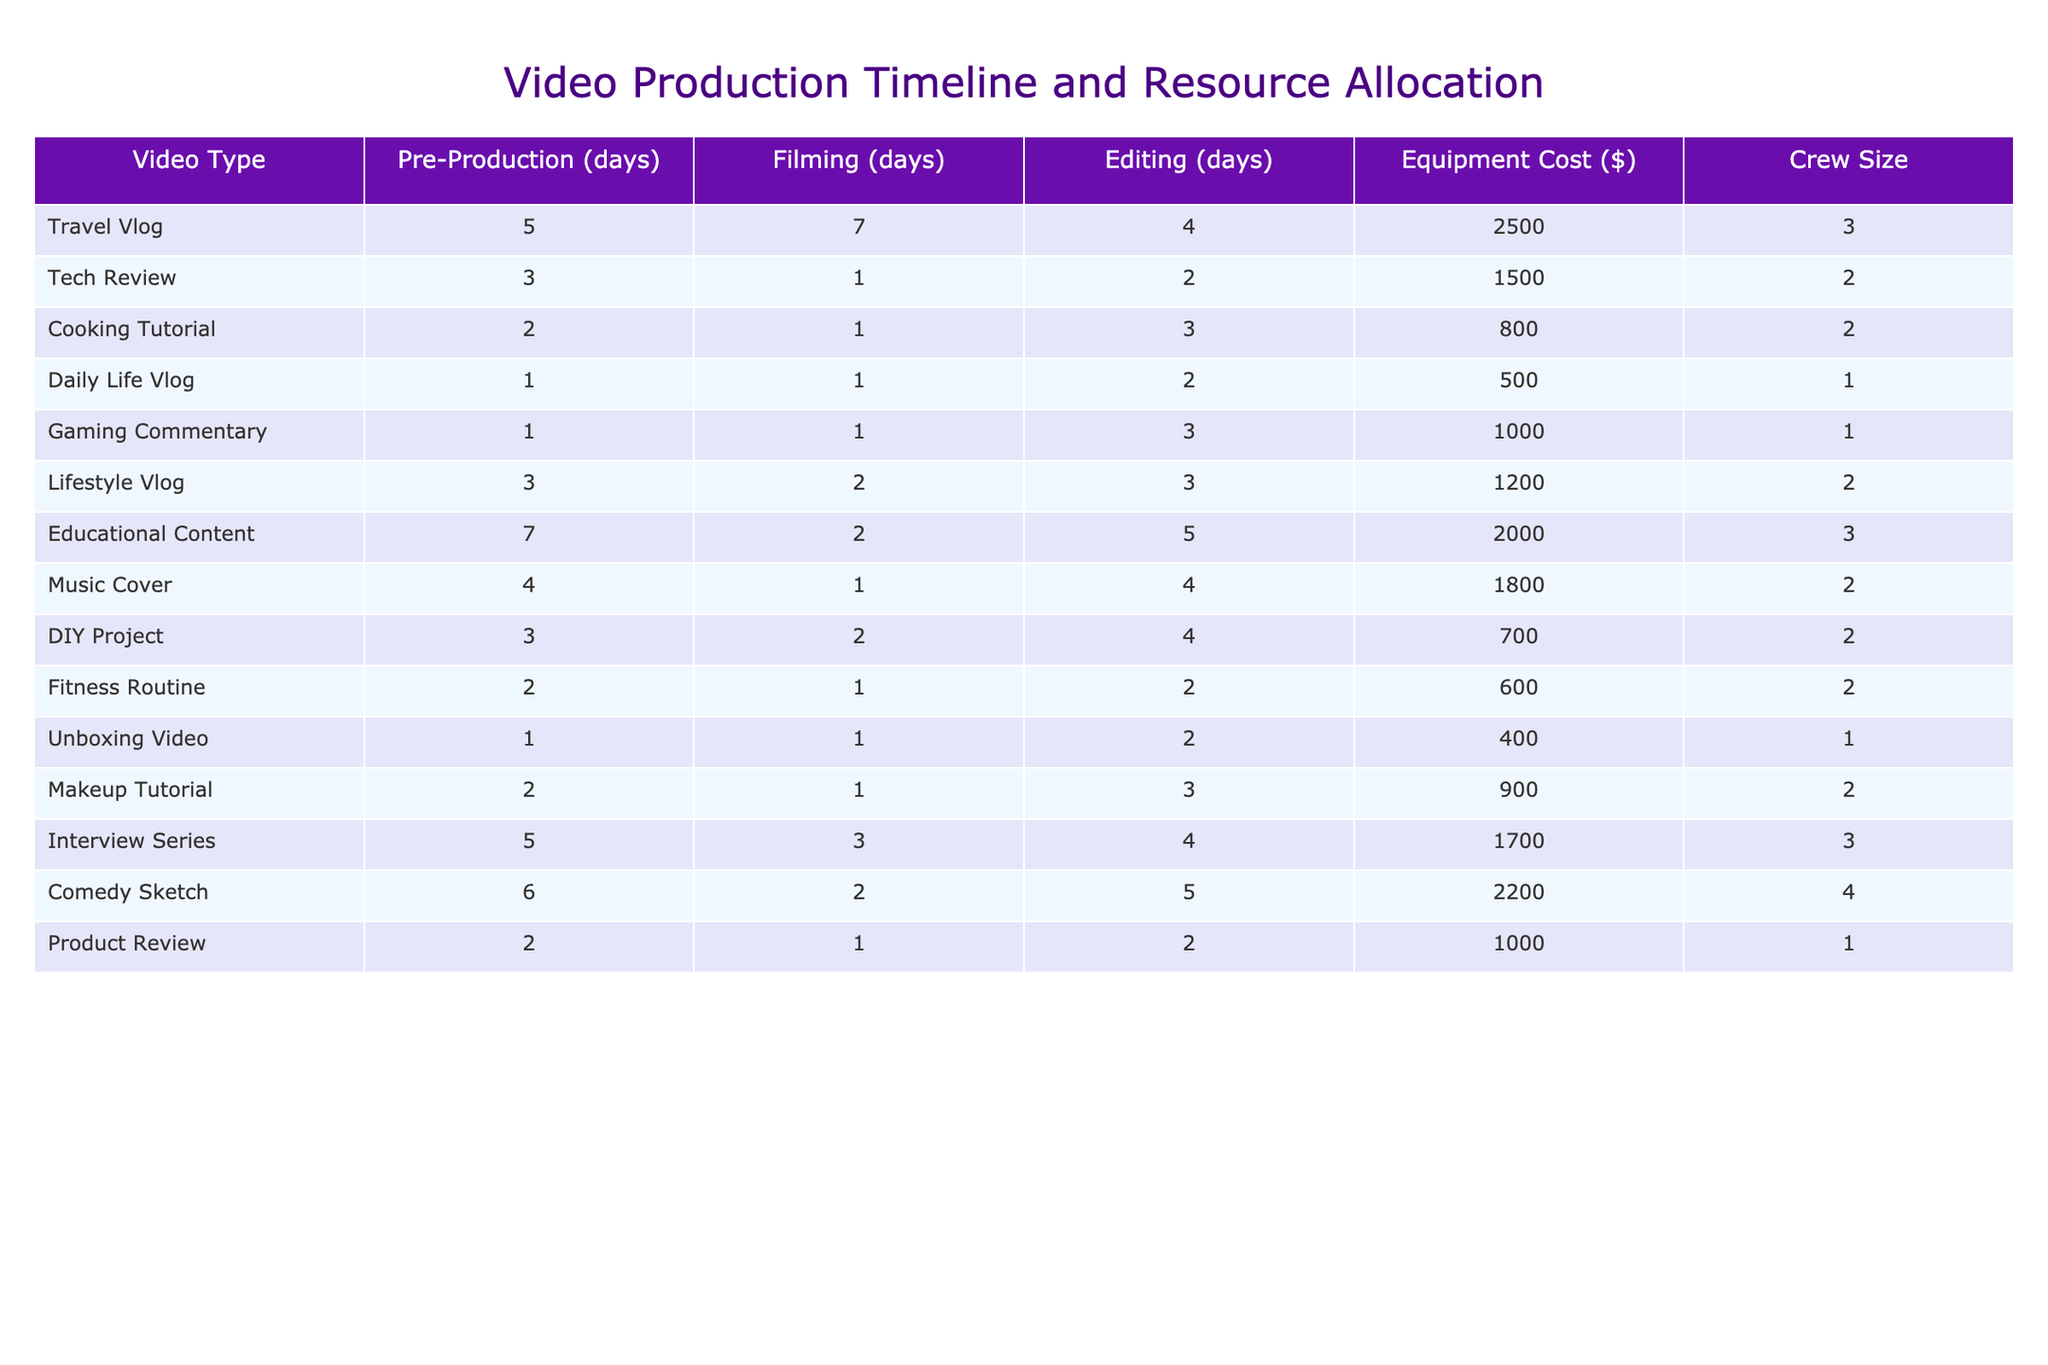What is the total filming time required for a Travel Vlog? The filming time is listed as 7 days for a Travel Vlog.
Answer: 7 days Which video type has the highest equipment cost? By comparing the Equipment Cost column, the Comedy Sketch has the highest cost at $2200.
Answer: $2200 How many days does it take to edit a Cooking Tutorial? The editing time for a Cooking Tutorial is 3 days as indicated in the table.
Answer: 3 days What is the average pre-production time across all video types? To find the average, we sum the pre-production days: 5 + 3 + 2 + 1 + 1 + 3 + 7 + 4 + 3 + 2 + 2 + 5 + 6 + 2 = 46. There are 14 vlogs, so the average is 46/14 ≈ 3.29 days.
Answer: 3.29 days Is the crew size for a Daily Life Vlog greater than that of a Gaming Commentary? The crew size for a Daily Life Vlog is 1, while for a Gaming Commentary it's also 1. Therefore, the statement is false.
Answer: No What is the total duration (in days) from pre-production to editing for a Fitness Routine? For a Fitness Routine, add pre-production (2 days), filming (1 day), and editing (2 days): 2 + 1 + 2 = 5 days.
Answer: 5 days Which video type requires the least amount of editing time? The minimum editing time listed is 2 days, which applies to both Daily Life Vlog and Product Review.
Answer: 2 days How does the crew size of Educational Content compare to that of Tech Review? Educational Content has a crew size of 3, whereas Tech Review has a crew size of 2. Thus, Educational Content has a larger crew size.
Answer: Larger What is the difference in filming days between a Comedy Sketch and a Tech Review? A Comedy Sketch has 2 filming days while a Tech Review has 1 day, so the difference is 2 - 1 = 1 day.
Answer: 1 day Which video type takes the longest total time from pre-production through editing? First calculate the total time for each video: 
Travel Vlog: 5 + 7 + 4 = 16, 
Tech Review: 3 + 1 + 2 = 6, 
Cooking Tutorial: 2 + 1 + 3 = 6, 
Daily Life Vlog: 1 + 1 + 2 = 4, 
Gaming Commentary: 1 + 1 + 3 = 5, 
Lifestyle Vlog: 3 + 2 + 3 = 8, 
Educational Content: 7 + 2 + 5 = 14, 
Music Cover: 4 + 1 + 4 = 9, 
DIY Project: 3 + 2 + 4 = 9, 
Fitness Routine: 2 + 1 + 2 = 5, 
Unboxing Video: 1 + 1 + 2 = 4, 
Makeup Tutorial: 2 + 1 + 3 = 6, 
Interview Series: 5 + 3 + 4 = 12, 
Comedy Sketch: 6 + 2 + 5 = 13, 
Product Review: 2 + 1 + 2 = 5. 
The maximum total is 16 for Travel Vlog.
Answer: Travel Vlog 